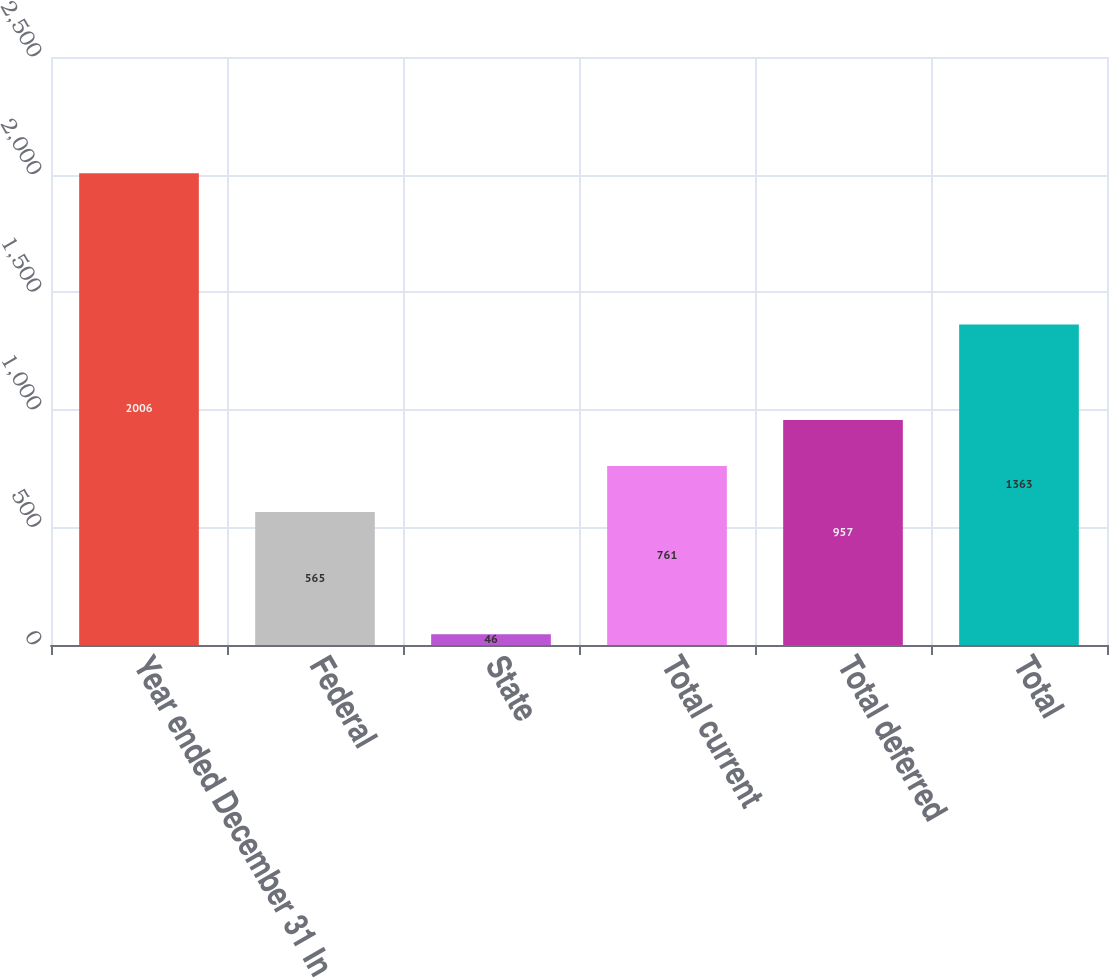Convert chart to OTSL. <chart><loc_0><loc_0><loc_500><loc_500><bar_chart><fcel>Year ended December 31 In<fcel>Federal<fcel>State<fcel>Total current<fcel>Total deferred<fcel>Total<nl><fcel>2006<fcel>565<fcel>46<fcel>761<fcel>957<fcel>1363<nl></chart> 